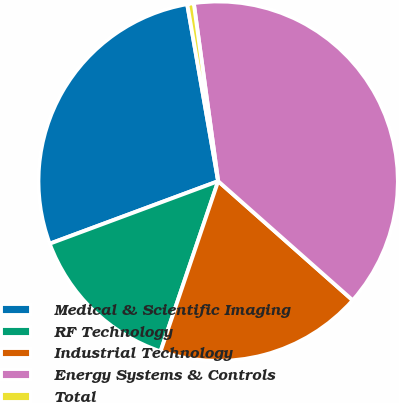Convert chart. <chart><loc_0><loc_0><loc_500><loc_500><pie_chart><fcel>Medical & Scientific Imaging<fcel>RF Technology<fcel>Industrial Technology<fcel>Energy Systems & Controls<fcel>Total<nl><fcel>27.9%<fcel>14.15%<fcel>18.66%<fcel>38.7%<fcel>0.59%<nl></chart> 